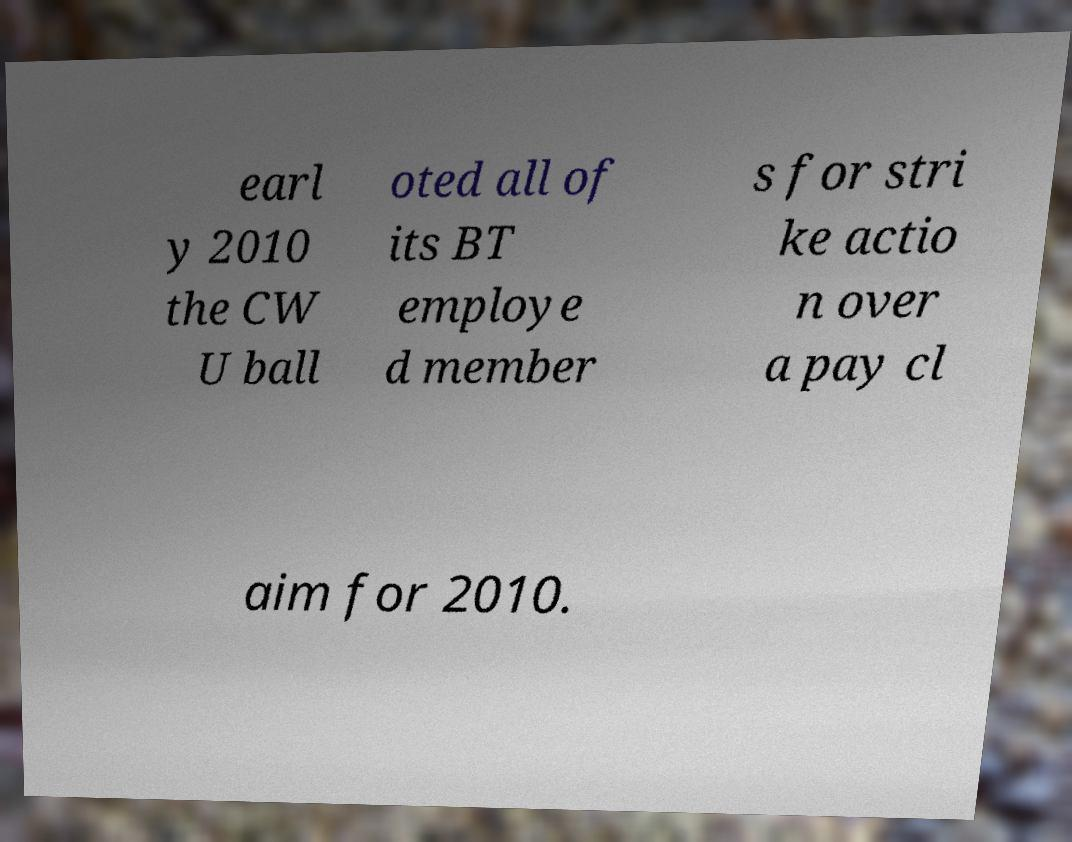Could you extract and type out the text from this image? earl y 2010 the CW U ball oted all of its BT employe d member s for stri ke actio n over a pay cl aim for 2010. 